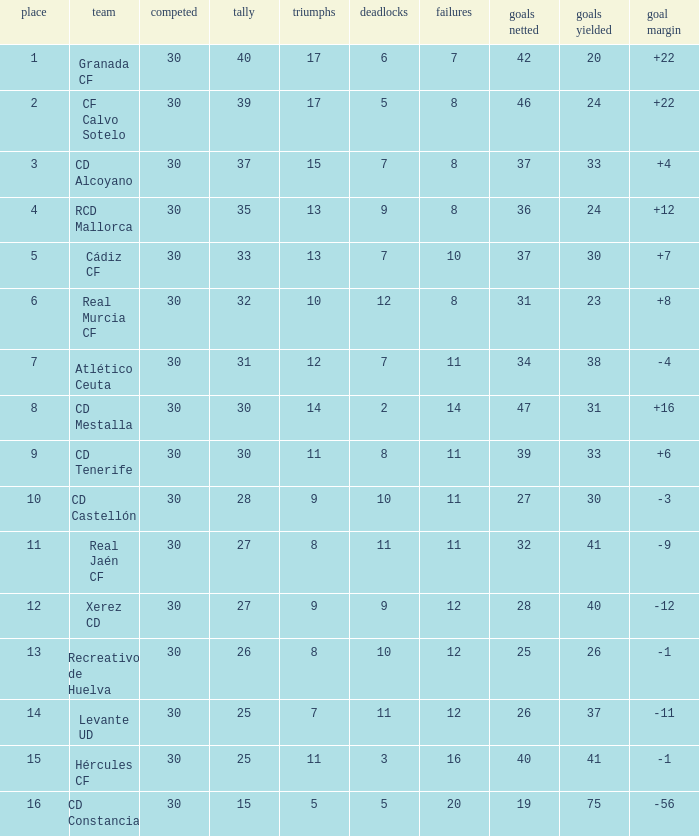Which Wins have a Goal Difference larger than 12, and a Club of granada cf, and Played larger than 30? None. 